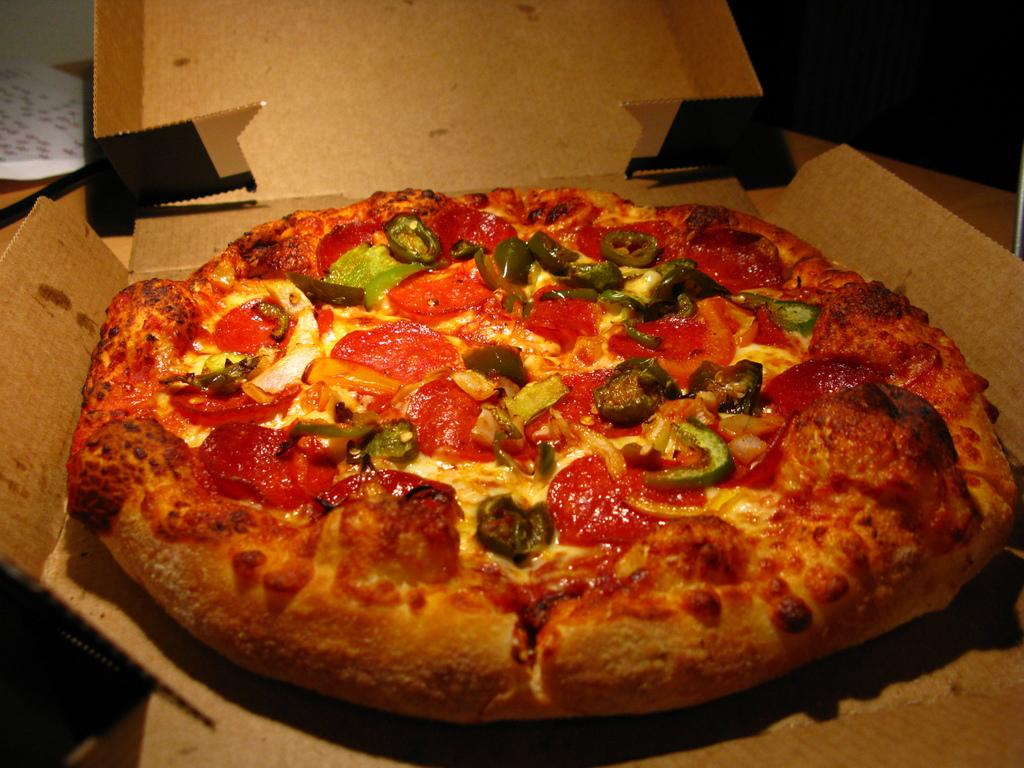What type of food is shown in the image? There is a pizza in the image. How is the pizza presented? The pizza is on a cardboard box. What can be said about the appearance of the pizza? The pizza is colorful. What is located to the left of the pizza? There is a white paper to the left of the pizza. On what surface is the white paper placed? The white paper is on a brown surface. What type of jam is being spread on the pizza in the image? There is no jam present in the image; it features a pizza on a cardboard box. What is the sun doing in the image? There is no sun depicted in the image; it focuses on a pizza and a white paper on a brown surface. 